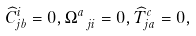<formula> <loc_0><loc_0><loc_500><loc_500>\widehat { C } _ { j b } ^ { i } = 0 , \Omega _ { \ j i } ^ { a } = 0 , \widehat { T } _ { j a } ^ { c } = 0 ,</formula> 